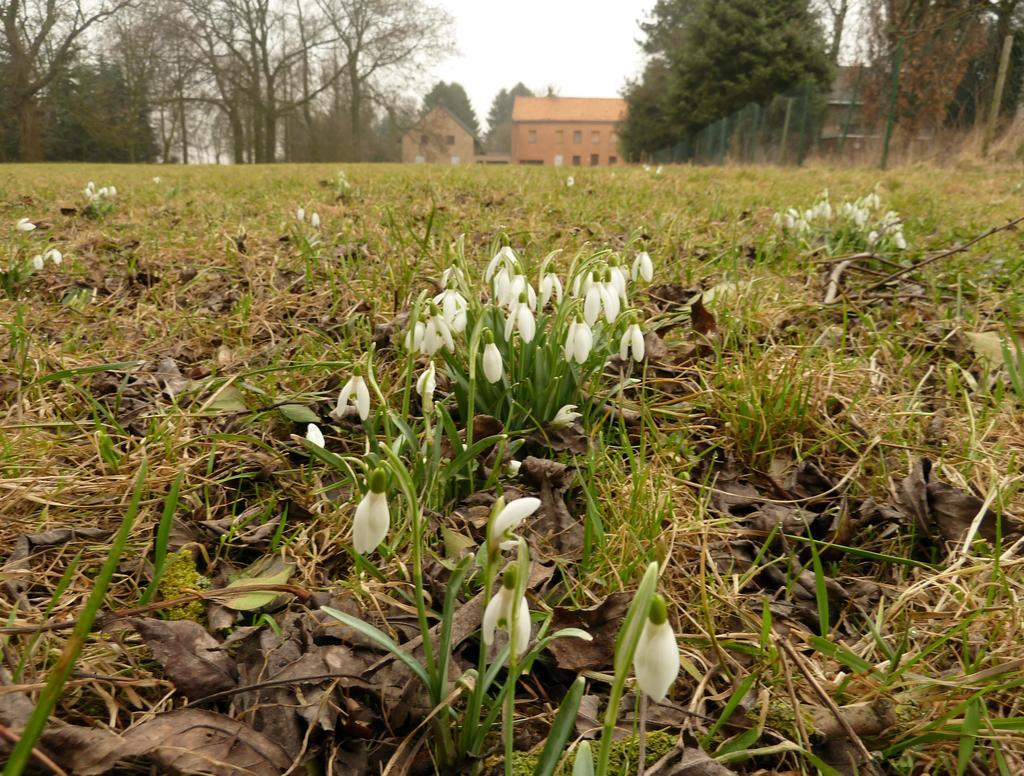What is located in the front of the image? There is a plant in the front of the image. What type of vegetation is on the ground in the center of the image? There is grass on the ground in the center of the image. What can be seen in the background of the image? There are trees and buildings in the background of the image. How would you describe the sky in the image? The sky is cloudy in the image. What type of game is being played in the image? There is no game being played in the image; it features a plant, grass, trees, buildings, and a cloudy sky. Is there a fire visible in the image? No, there is no fire present in the image. 